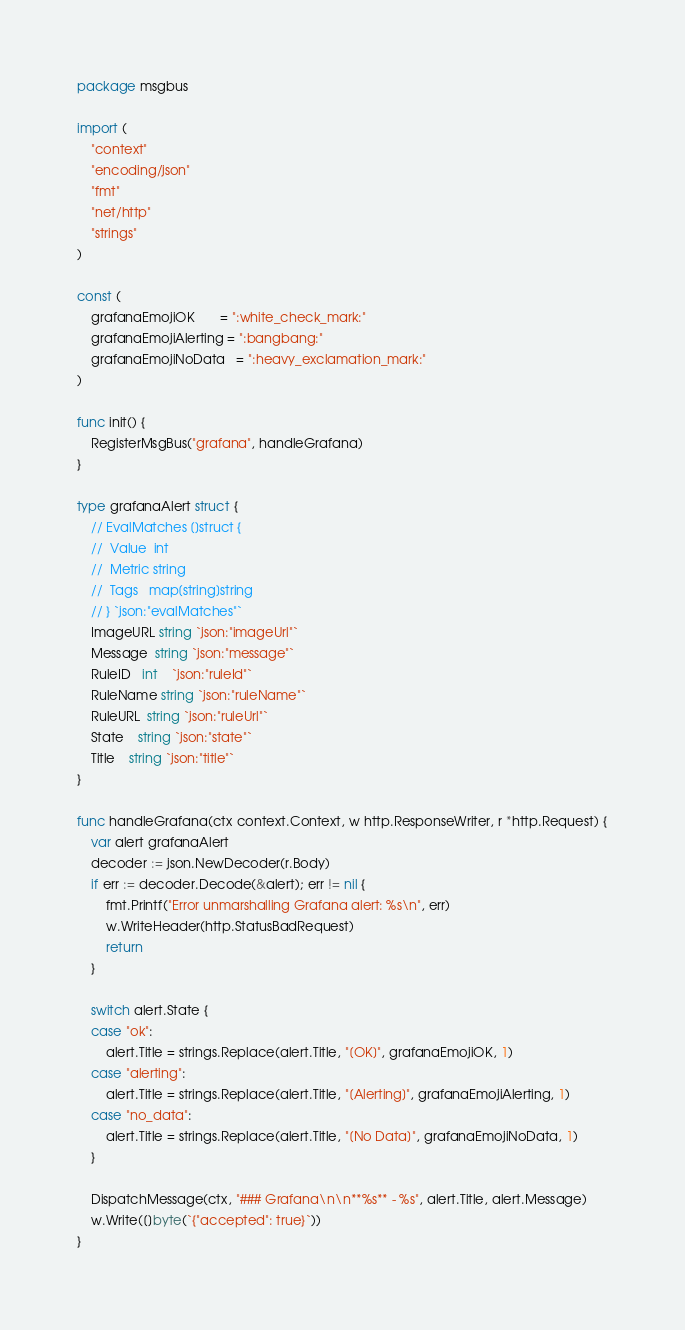Convert code to text. <code><loc_0><loc_0><loc_500><loc_500><_Go_>package msgbus

import (
	"context"
	"encoding/json"
	"fmt"
	"net/http"
	"strings"
)

const (
	grafanaEmojiOK       = ":white_check_mark:"
	grafanaEmojiAlerting = ":bangbang:"
	grafanaEmojiNoData   = ":heavy_exclamation_mark:"
)

func init() {
	RegisterMsgBus("grafana", handleGrafana)
}

type grafanaAlert struct {
	// EvalMatches []struct {
	// 	Value  int
	// 	Metric string
	// 	Tags   map[string]string
	// } `json:"evalMatches"`
	ImageURL string `json:"imageUrl"`
	Message  string `json:"message"`
	RuleID   int    `json:"ruleId"`
	RuleName string `json:"ruleName"`
	RuleURL  string `json:"ruleUrl"`
	State    string `json:"state"`
	Title    string `json:"title"`
}

func handleGrafana(ctx context.Context, w http.ResponseWriter, r *http.Request) {
	var alert grafanaAlert
	decoder := json.NewDecoder(r.Body)
	if err := decoder.Decode(&alert); err != nil {
		fmt.Printf("Error unmarshalling Grafana alert: %s\n", err)
		w.WriteHeader(http.StatusBadRequest)
		return
	}

	switch alert.State {
	case "ok":
		alert.Title = strings.Replace(alert.Title, "[OK]", grafanaEmojiOK, 1)
	case "alerting":
		alert.Title = strings.Replace(alert.Title, "[Alerting]", grafanaEmojiAlerting, 1)
	case "no_data":
		alert.Title = strings.Replace(alert.Title, "[No Data]", grafanaEmojiNoData, 1)
	}

	DispatchMessage(ctx, "### Grafana\n\n**%s** - %s", alert.Title, alert.Message)
	w.Write([]byte(`{"accepted": true}`))
}
</code> 